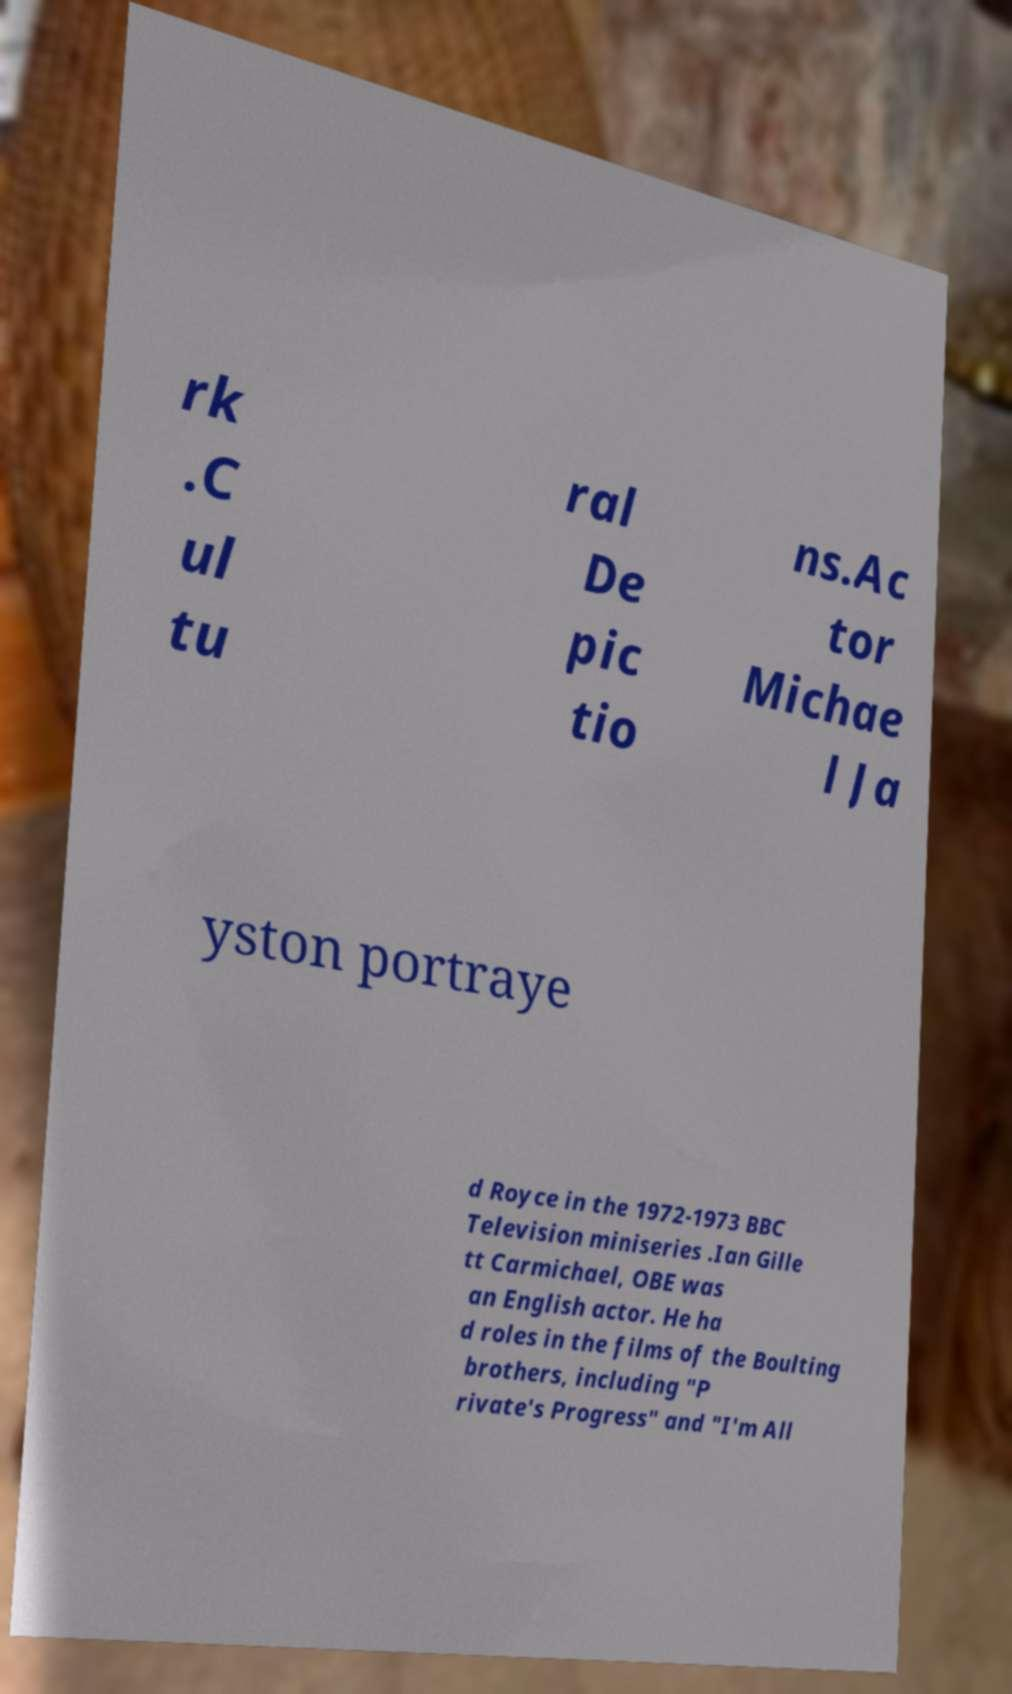Could you extract and type out the text from this image? rk .C ul tu ral De pic tio ns.Ac tor Michae l Ja yston portraye d Royce in the 1972-1973 BBC Television miniseries .Ian Gille tt Carmichael, OBE was an English actor. He ha d roles in the films of the Boulting brothers, including "P rivate's Progress" and "I'm All 